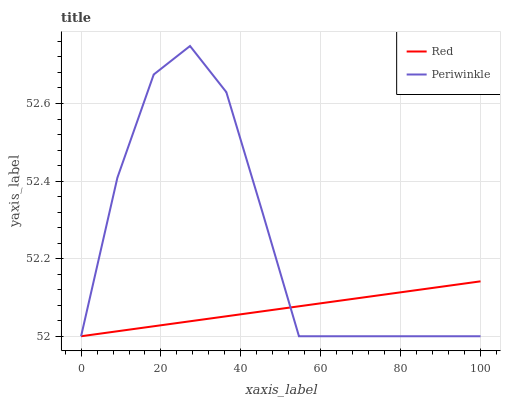Does Red have the minimum area under the curve?
Answer yes or no. Yes. Does Periwinkle have the maximum area under the curve?
Answer yes or no. Yes. Does Red have the maximum area under the curve?
Answer yes or no. No. Is Red the smoothest?
Answer yes or no. Yes. Is Periwinkle the roughest?
Answer yes or no. Yes. Is Red the roughest?
Answer yes or no. No. Does Periwinkle have the lowest value?
Answer yes or no. Yes. Does Periwinkle have the highest value?
Answer yes or no. Yes. Does Red have the highest value?
Answer yes or no. No. Does Periwinkle intersect Red?
Answer yes or no. Yes. Is Periwinkle less than Red?
Answer yes or no. No. Is Periwinkle greater than Red?
Answer yes or no. No. 